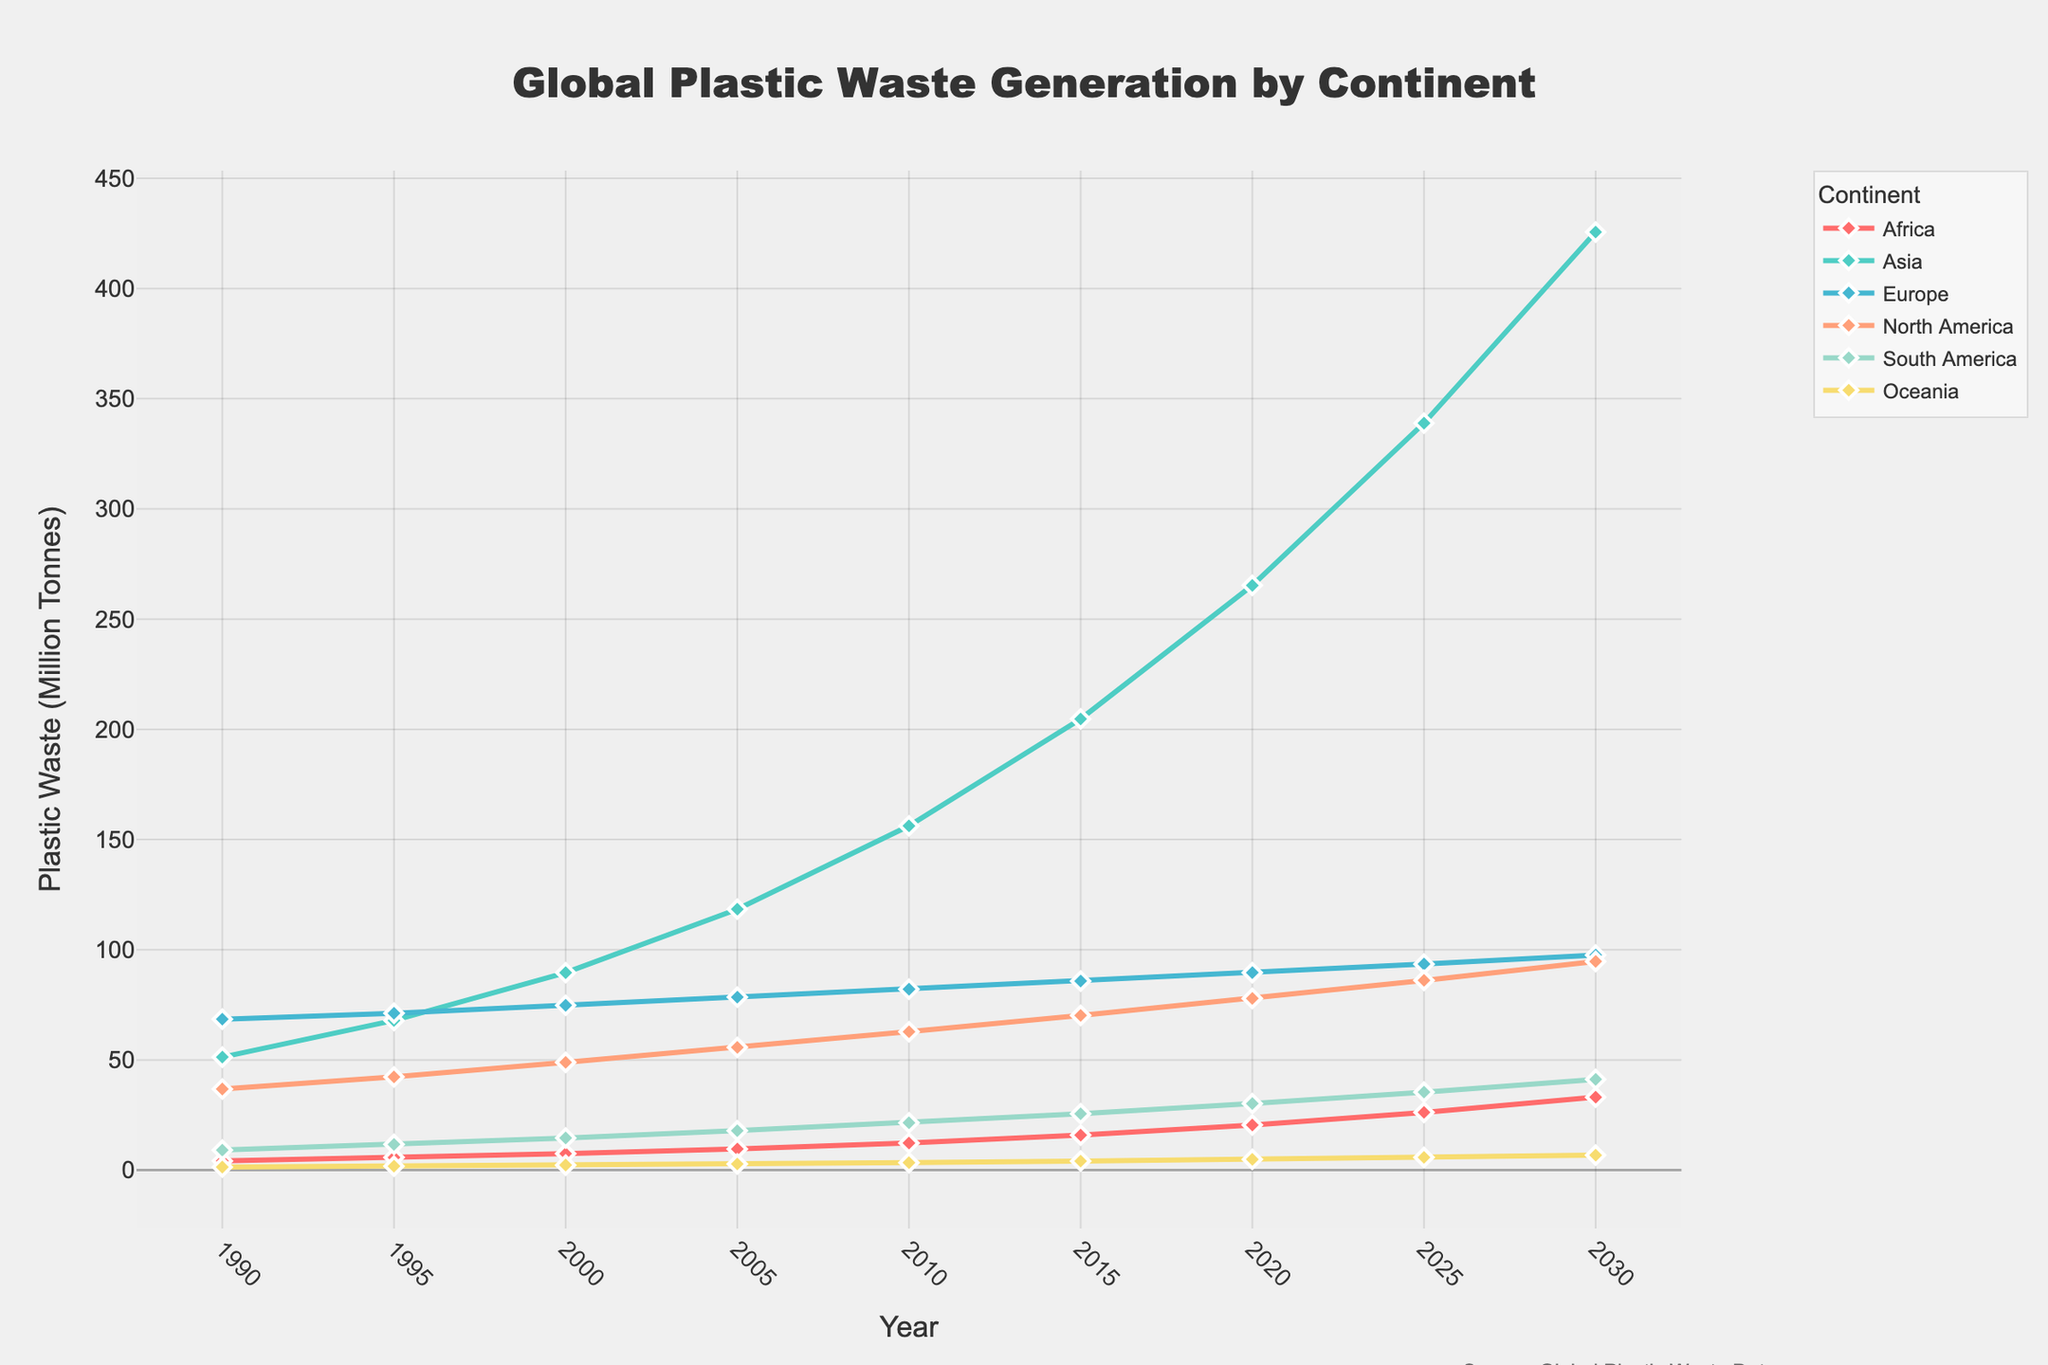Which continent had the highest plastic waste generation in 1990? By analyzing the data, the highest plastic waste generation in 1990 is the tallest line, which belongs to Europe.
Answer: Europe What is the trend of plastic waste generation in Asia from 1990 to 2030? Observing the plot, the line for Asia shows a consistent upward trend from 1990 to 2030, indicating a continuous increase in plastic waste generation.
Answer: Increasing Which two continents had similar plastic waste generation in 1995? By comparing the heights of the lines at 1995, North America and Europe had similar values, as their lines are close to the same level.
Answer: North America and Europe How many years did it take for Africa's plastic waste generation to rise from 4.2 million tonnes to 20.5 million tonnes? The value 4.2 is found in 1990 and 20.5 is in 2020, subtracting these years gives 2020 - 1990 = 30 years.
Answer: 30 years Between which years did South America see the largest increase in plastic waste generation? Compare the slope of South America's line between each interval; from 2020 to 2025 (30.2 to 35.4) indicates the largest increase as the slope is steepest.
Answer: 2020 to 2025 What is the difference in plastic waste generation between North America and Oceania in 2030? Look at the values for North America and Oceania in 2030: 94.7 and 6.8 respectively. Subtract Oceania from North America: 94.7 - 6.8 = 87.9 million tonnes.
Answer: 87.9 million tonnes What year did Europe’s plastic waste generation first surpass 85 million tonnes? Locate the point where Europe's line first crosses 85 million tonnes, which happens in 2015.
Answer: 2015 Rank the continents by plastic waste generation in 2030 from highest to lowest. By comparing the heights of lines at 2030, the order is: Asia, North America, Europe, South America, Africa, Oceania.
Answer: Asia, North America, Europe, South America, Africa, Oceania What has been the average annual growth in plastic waste generation for Africa from 1990 to 2030? The increase from 4.2 million tonnes to 33.1 million tonnes over 40 years is (33.1 - 4.2) / 40 = 28.9 / 40 = 0.7225 million tonnes per year.
Answer: 0.7225 million tonnes per year 